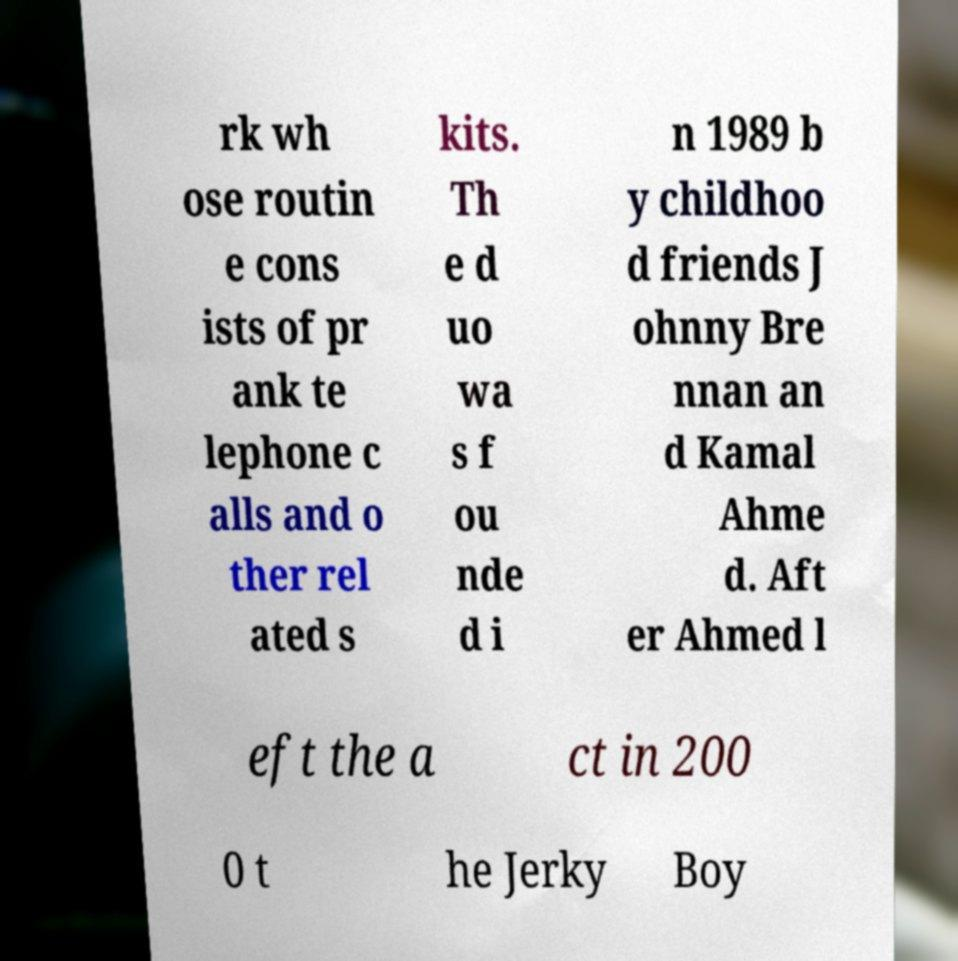Can you accurately transcribe the text from the provided image for me? rk wh ose routin e cons ists of pr ank te lephone c alls and o ther rel ated s kits. Th e d uo wa s f ou nde d i n 1989 b y childhoo d friends J ohnny Bre nnan an d Kamal Ahme d. Aft er Ahmed l eft the a ct in 200 0 t he Jerky Boy 